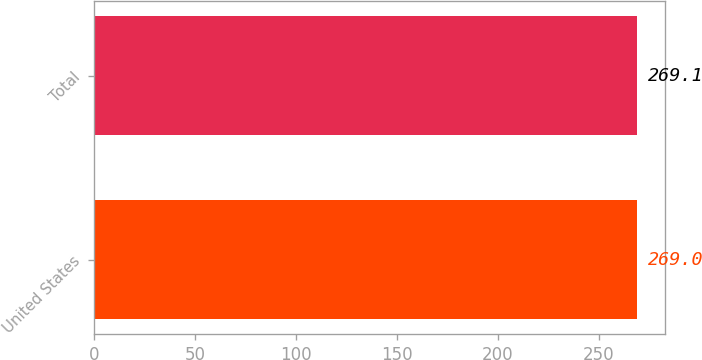Convert chart to OTSL. <chart><loc_0><loc_0><loc_500><loc_500><bar_chart><fcel>United States<fcel>Total<nl><fcel>269<fcel>269.1<nl></chart> 